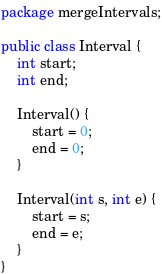Convert code to text. <code><loc_0><loc_0><loc_500><loc_500><_Java_>package mergeIntervals;

public class Interval {
    int start;
    int end;

    Interval() {
        start = 0;
        end = 0;
    }

    Interval(int s, int e) {
        start = s;
        end = e;
    }
}
</code> 